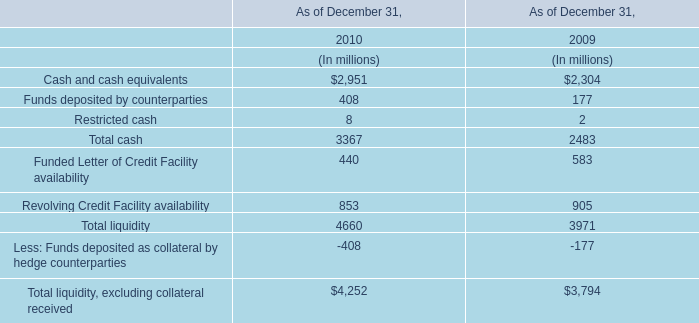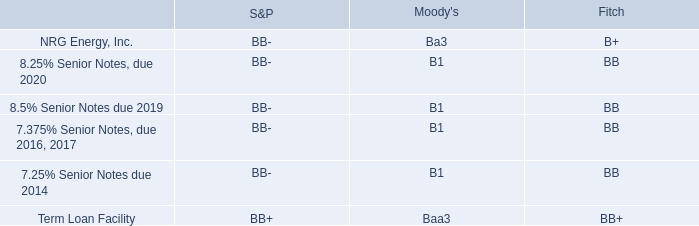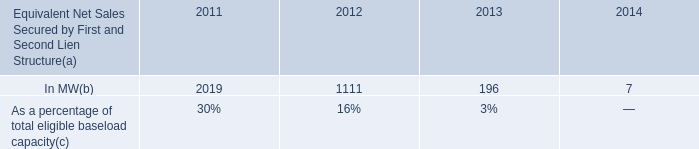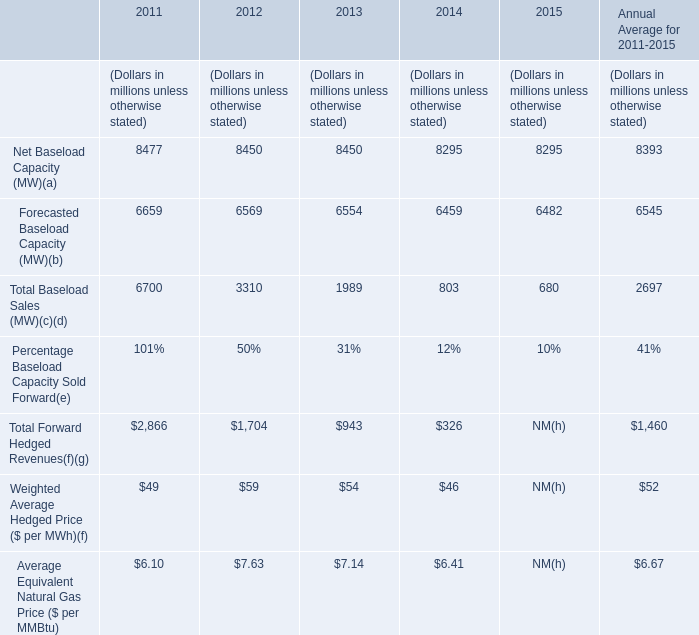What is the growing rate of Total Baseload Sales (MW) in the year with the most Total Forward Hedged Revenues? 
Computations: ((6700 - 3310) / 6700)
Answer: 0.50597. 